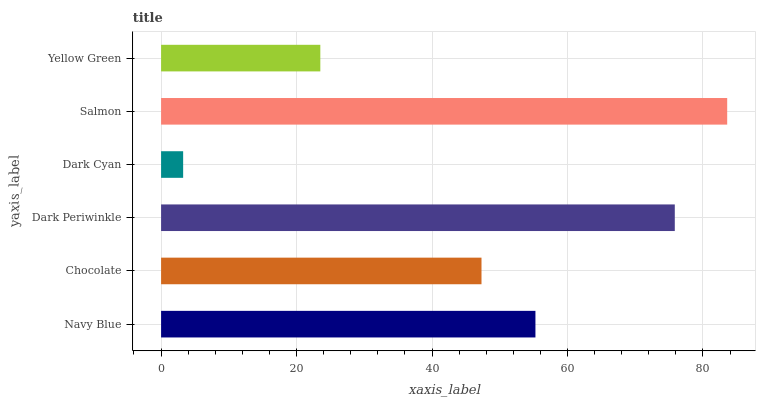Is Dark Cyan the minimum?
Answer yes or no. Yes. Is Salmon the maximum?
Answer yes or no. Yes. Is Chocolate the minimum?
Answer yes or no. No. Is Chocolate the maximum?
Answer yes or no. No. Is Navy Blue greater than Chocolate?
Answer yes or no. Yes. Is Chocolate less than Navy Blue?
Answer yes or no. Yes. Is Chocolate greater than Navy Blue?
Answer yes or no. No. Is Navy Blue less than Chocolate?
Answer yes or no. No. Is Navy Blue the high median?
Answer yes or no. Yes. Is Chocolate the low median?
Answer yes or no. Yes. Is Dark Cyan the high median?
Answer yes or no. No. Is Yellow Green the low median?
Answer yes or no. No. 